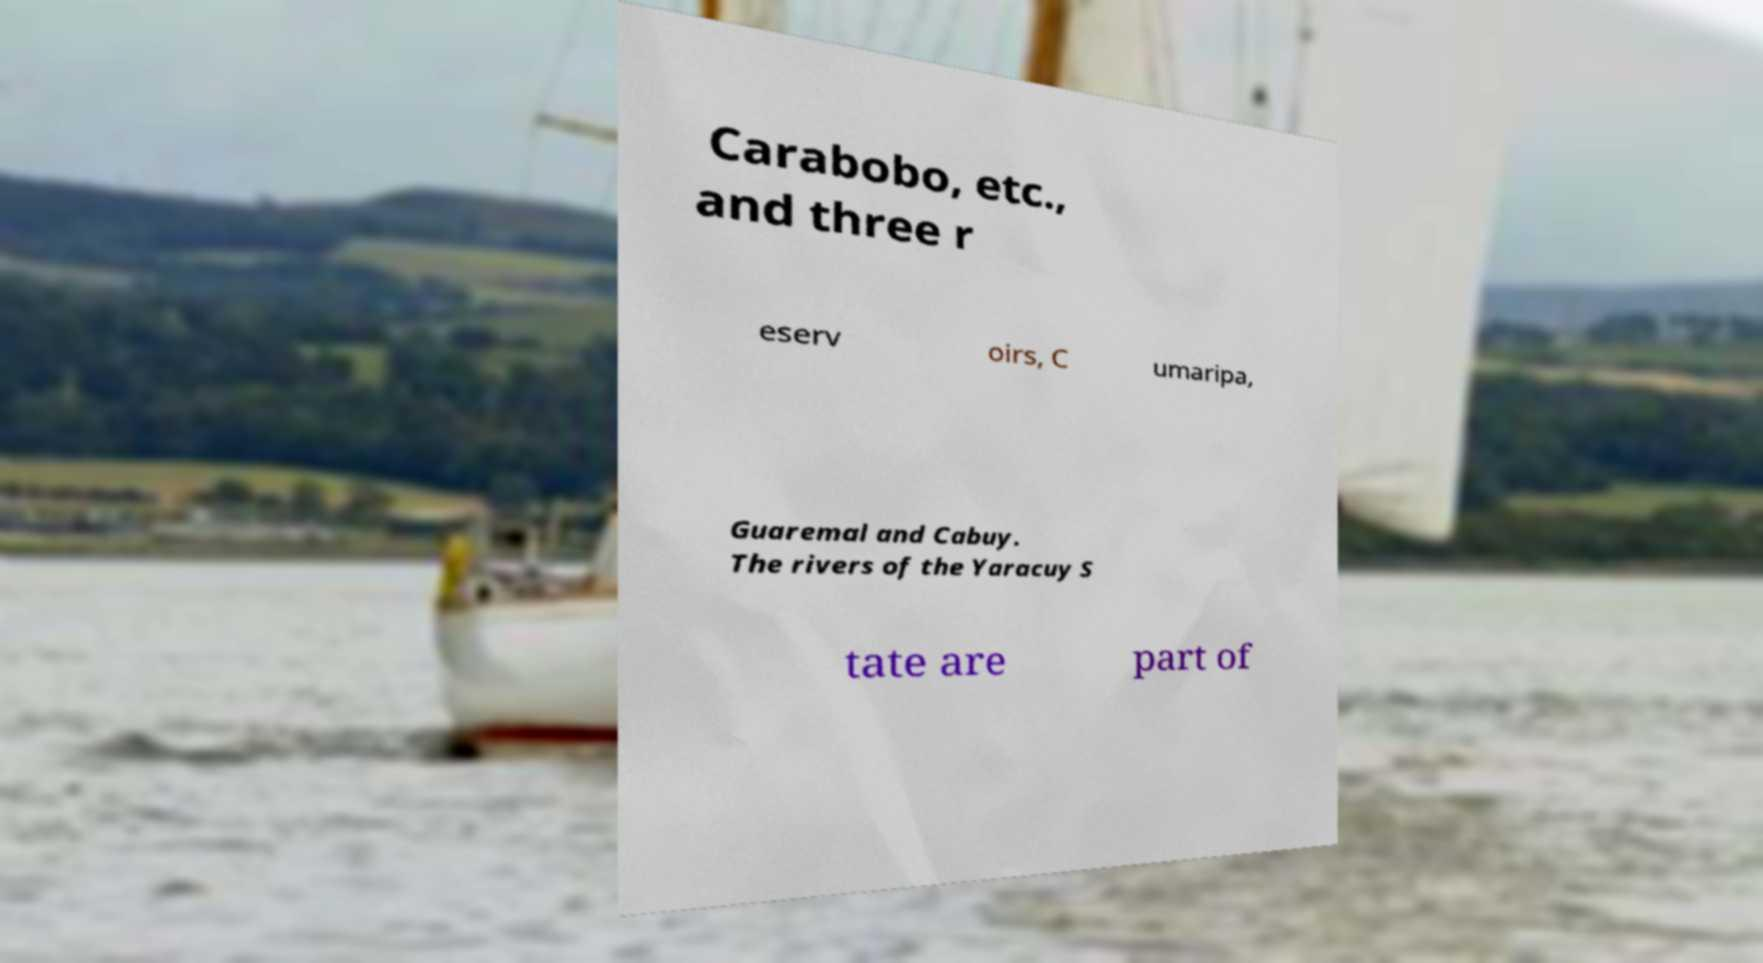I need the written content from this picture converted into text. Can you do that? Carabobo, etc., and three r eserv oirs, C umaripa, Guaremal and Cabuy. The rivers of the Yaracuy S tate are part of 